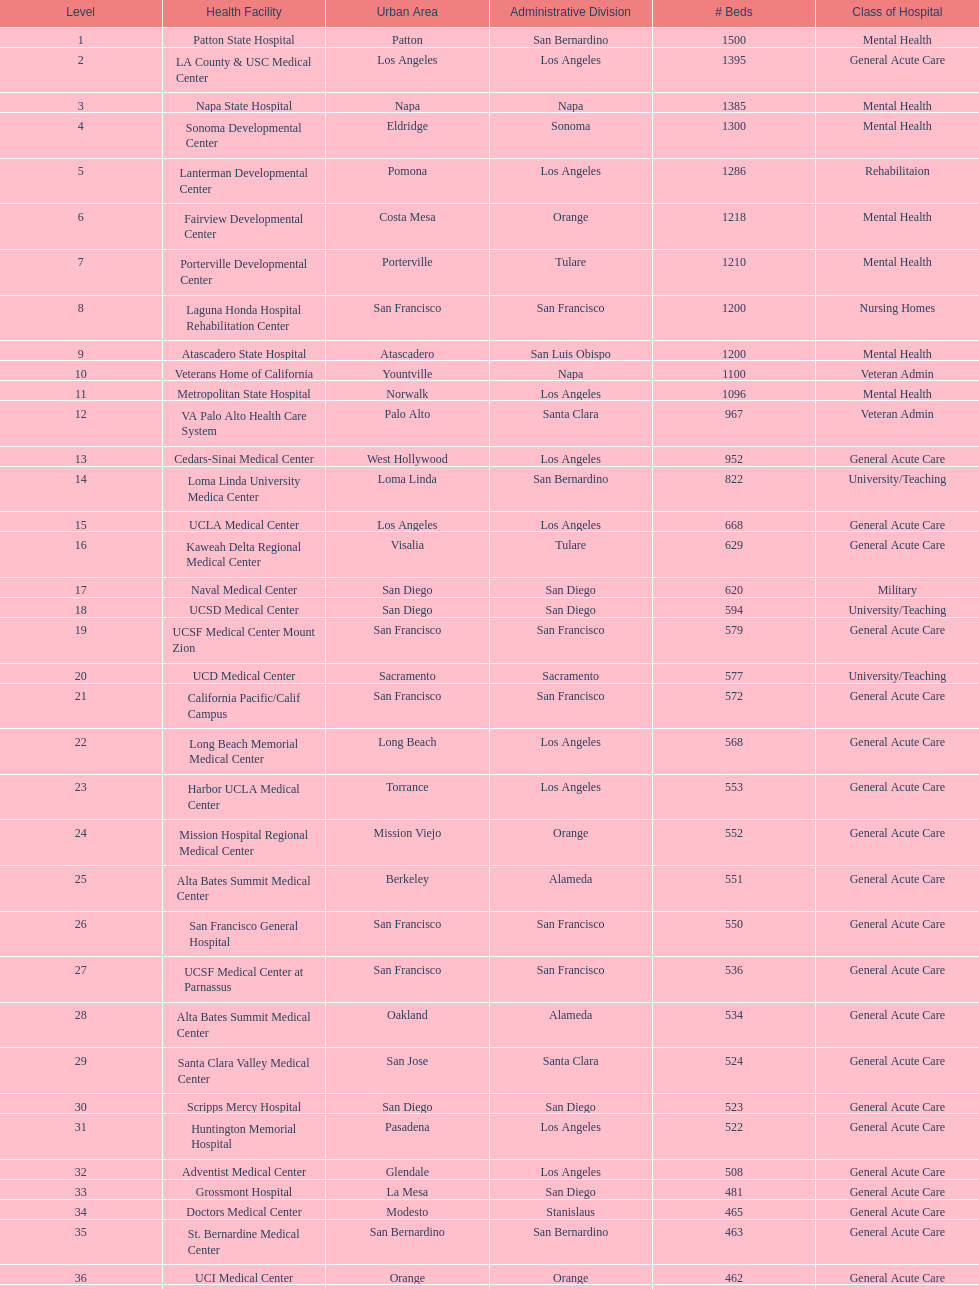How many more general acute care hospitals are there in california than rehabilitation hospitals? 33. 